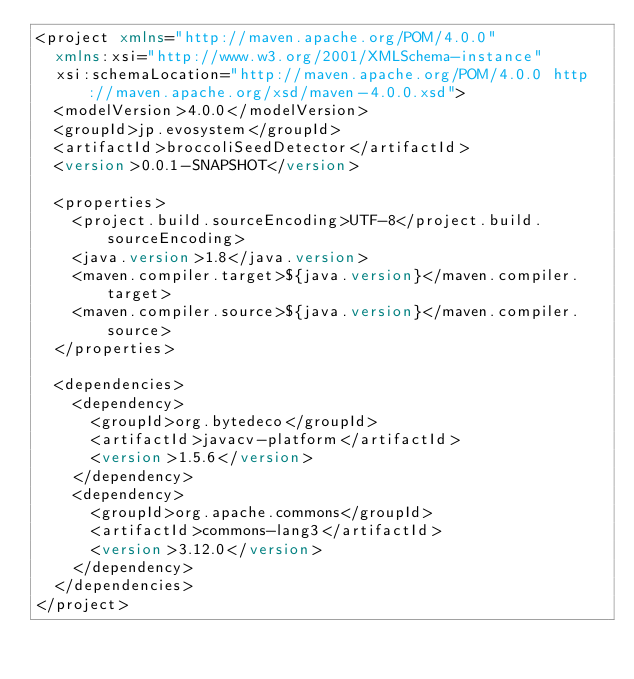Convert code to text. <code><loc_0><loc_0><loc_500><loc_500><_XML_><project xmlns="http://maven.apache.org/POM/4.0.0"
	xmlns:xsi="http://www.w3.org/2001/XMLSchema-instance"
	xsi:schemaLocation="http://maven.apache.org/POM/4.0.0 http://maven.apache.org/xsd/maven-4.0.0.xsd">
	<modelVersion>4.0.0</modelVersion>
	<groupId>jp.evosystem</groupId>
	<artifactId>broccoliSeedDetector</artifactId>
	<version>0.0.1-SNAPSHOT</version>

	<properties>
		<project.build.sourceEncoding>UTF-8</project.build.sourceEncoding>
		<java.version>1.8</java.version>
		<maven.compiler.target>${java.version}</maven.compiler.target>
		<maven.compiler.source>${java.version}</maven.compiler.source>
	</properties>

	<dependencies>
		<dependency>
			<groupId>org.bytedeco</groupId>
			<artifactId>javacv-platform</artifactId>
			<version>1.5.6</version>
		</dependency>
		<dependency>
			<groupId>org.apache.commons</groupId>
			<artifactId>commons-lang3</artifactId>
			<version>3.12.0</version>
		</dependency>
	</dependencies>
</project></code> 